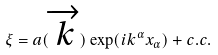<formula> <loc_0><loc_0><loc_500><loc_500>\xi = a ( \overrightarrow { k } ) \exp ( i k ^ { \alpha } x _ { \alpha } ) + c . c .</formula> 